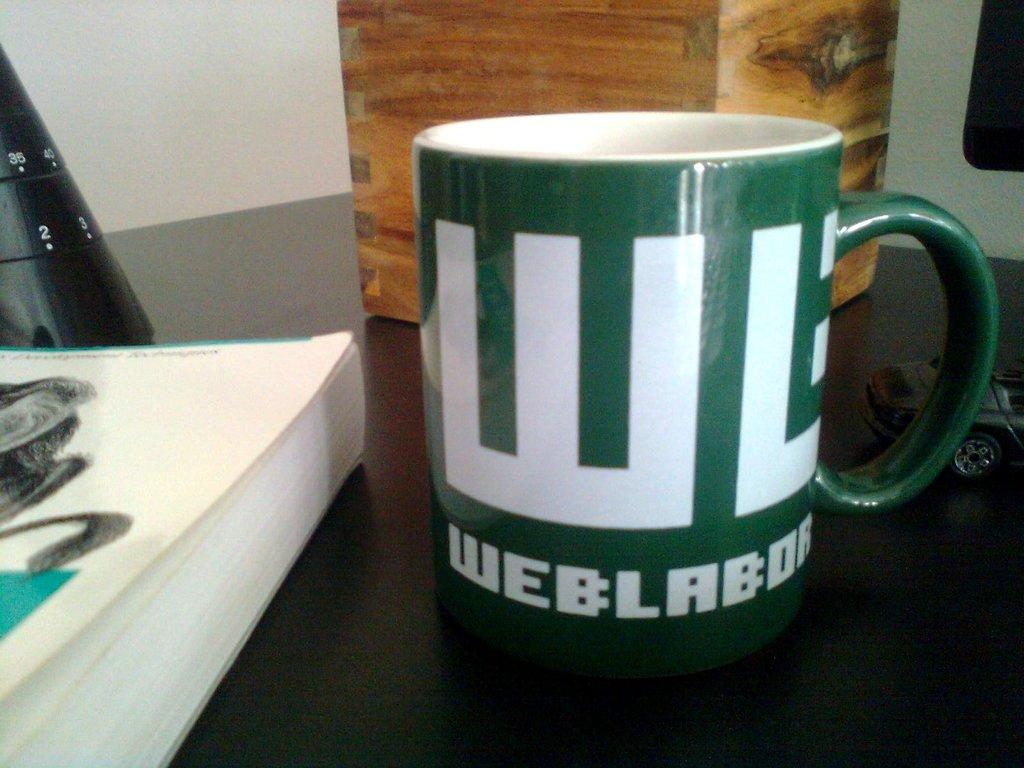Provide a one-sentence caption for the provided image. A green mug sits on a counter with the word Web written on it. 